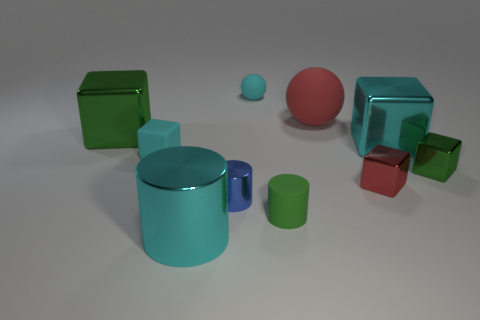Subtract 1 blocks. How many blocks are left? 4 Subtract all matte cubes. How many cubes are left? 4 Subtract all red blocks. How many blocks are left? 4 Subtract all red blocks. Subtract all brown cylinders. How many blocks are left? 4 Subtract all cylinders. How many objects are left? 7 Subtract all green cylinders. Subtract all small cyan rubber objects. How many objects are left? 7 Add 6 tiny green objects. How many tiny green objects are left? 8 Add 6 large cylinders. How many large cylinders exist? 7 Subtract 0 yellow blocks. How many objects are left? 10 